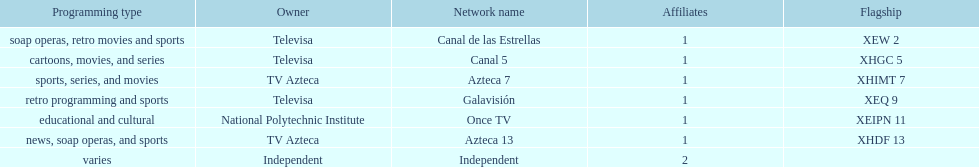Who is the exclusive network owner presented in a continuous order in the chart? Televisa. 